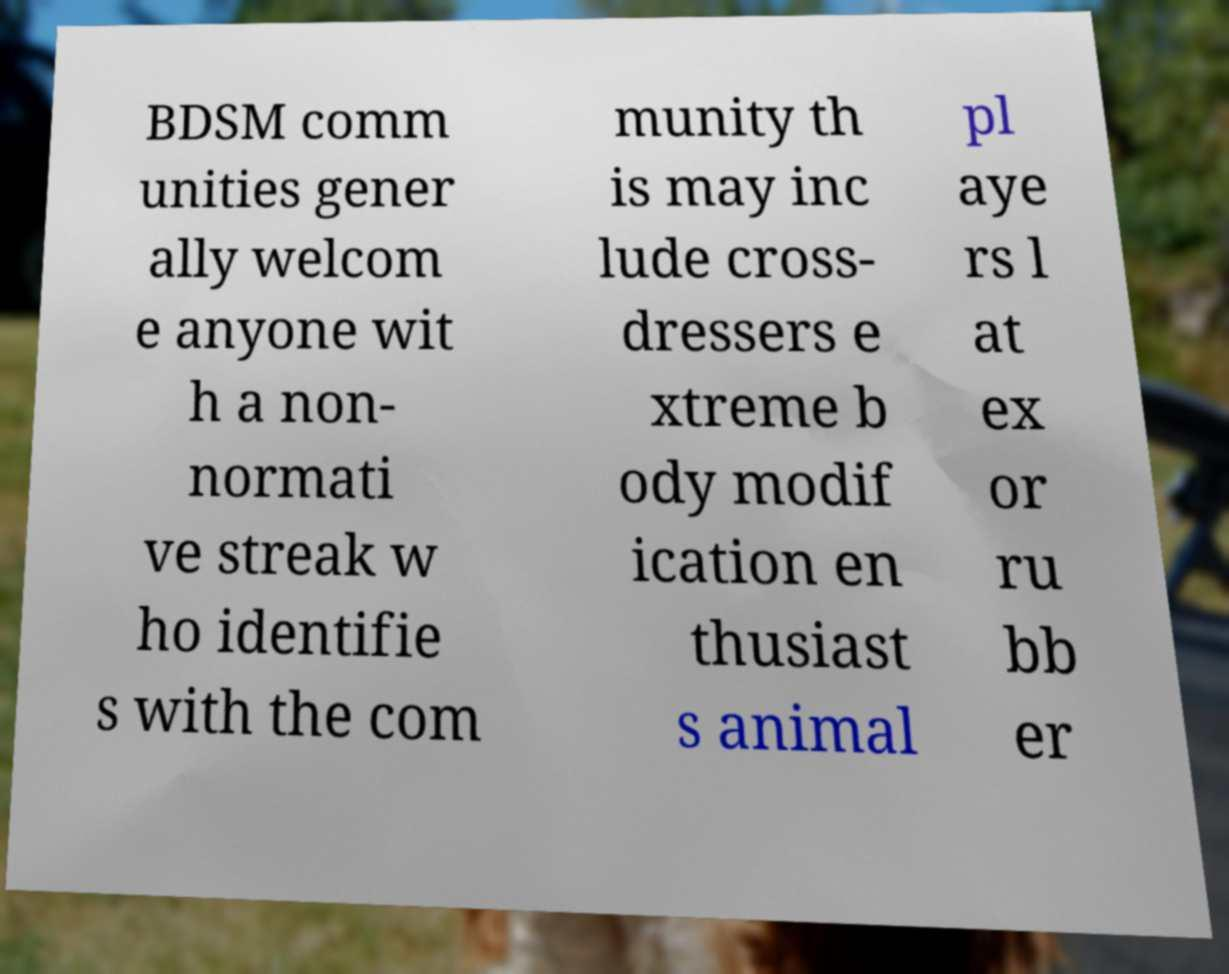There's text embedded in this image that I need extracted. Can you transcribe it verbatim? BDSM comm unities gener ally welcom e anyone wit h a non- normati ve streak w ho identifie s with the com munity th is may inc lude cross- dressers e xtreme b ody modif ication en thusiast s animal pl aye rs l at ex or ru bb er 